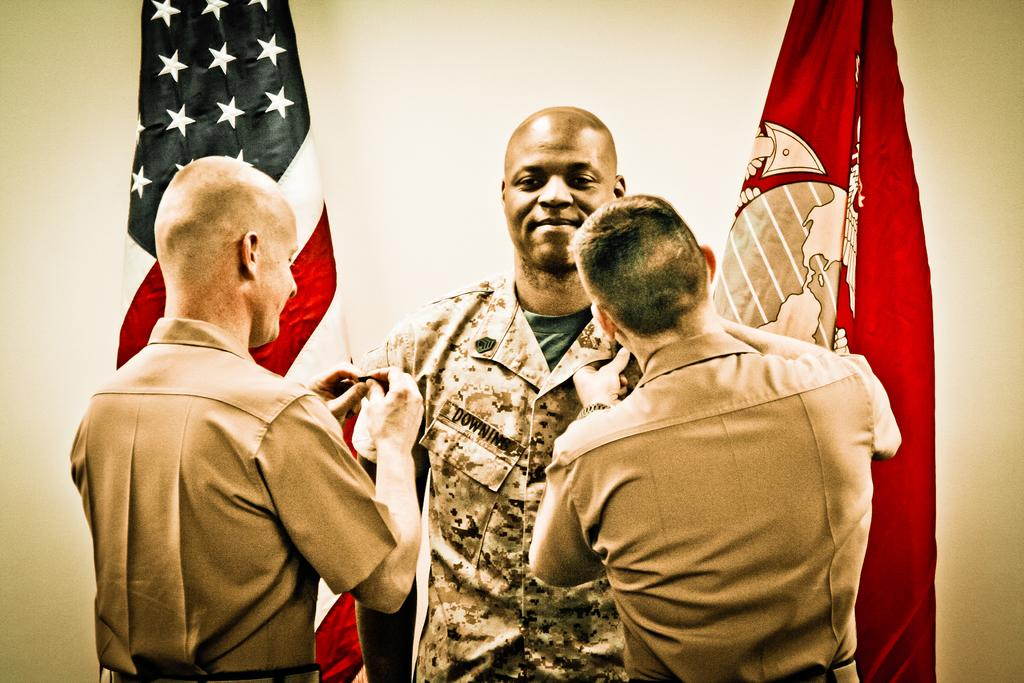Who can be seen in the image? There are people in the image. Can you describe the man in the middle of the image? The man in the middle of the image is smiling. What else is present in the image besides people? There are flags in the image. How many eggs are visible in the frame of the image? There are no eggs present in the image. 